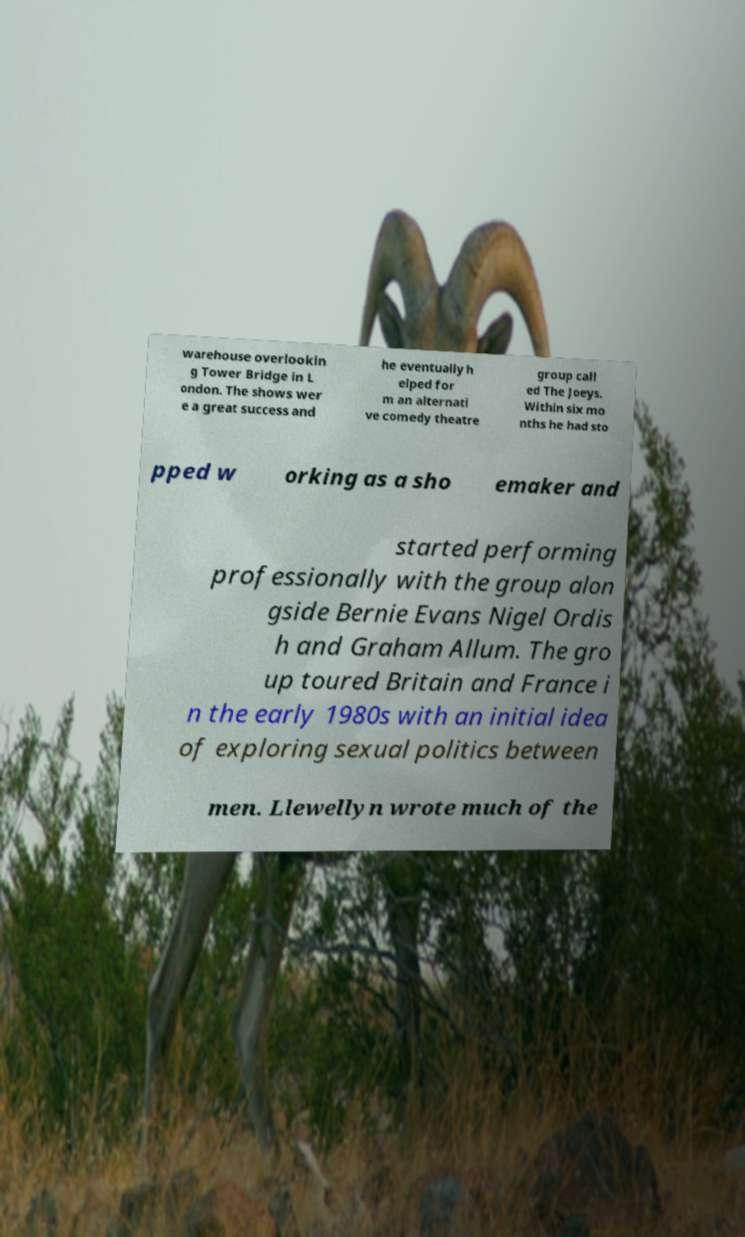What messages or text are displayed in this image? I need them in a readable, typed format. warehouse overlookin g Tower Bridge in L ondon. The shows wer e a great success and he eventually h elped for m an alternati ve comedy theatre group call ed The Joeys. Within six mo nths he had sto pped w orking as a sho emaker and started performing professionally with the group alon gside Bernie Evans Nigel Ordis h and Graham Allum. The gro up toured Britain and France i n the early 1980s with an initial idea of exploring sexual politics between men. Llewellyn wrote much of the 